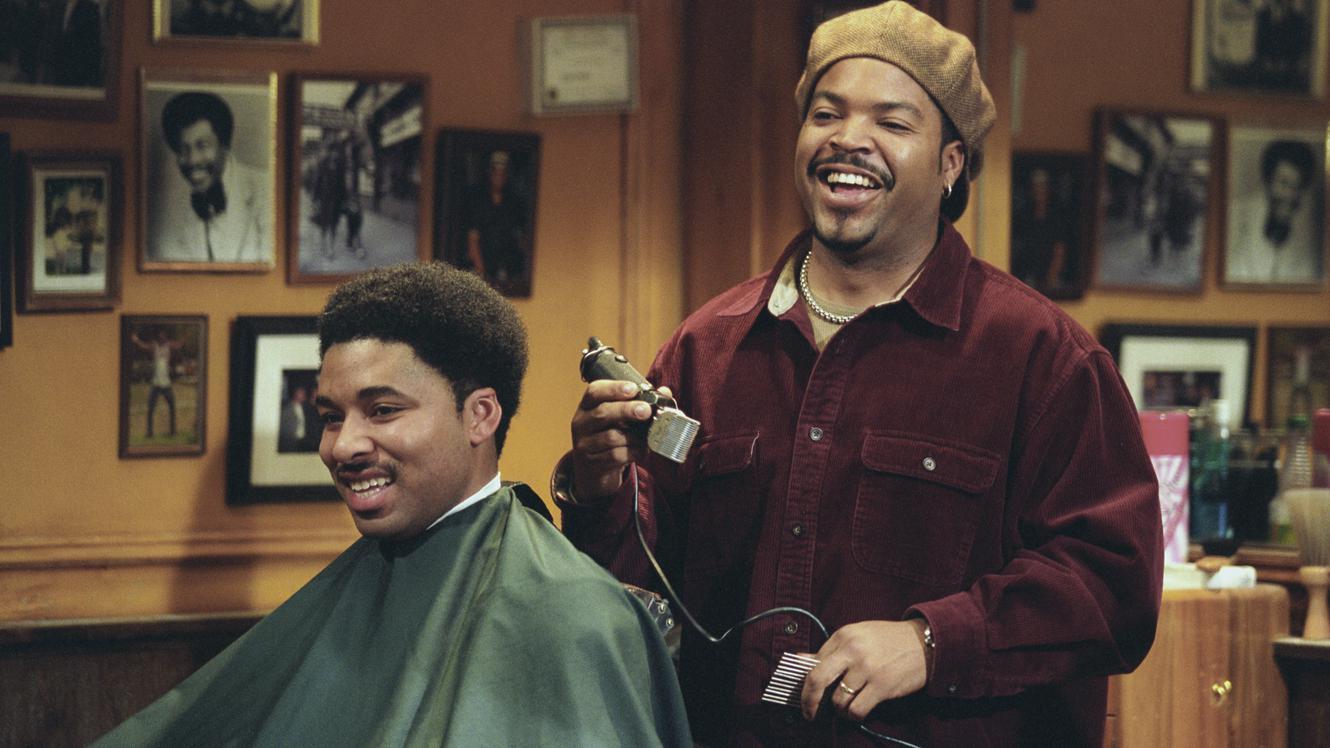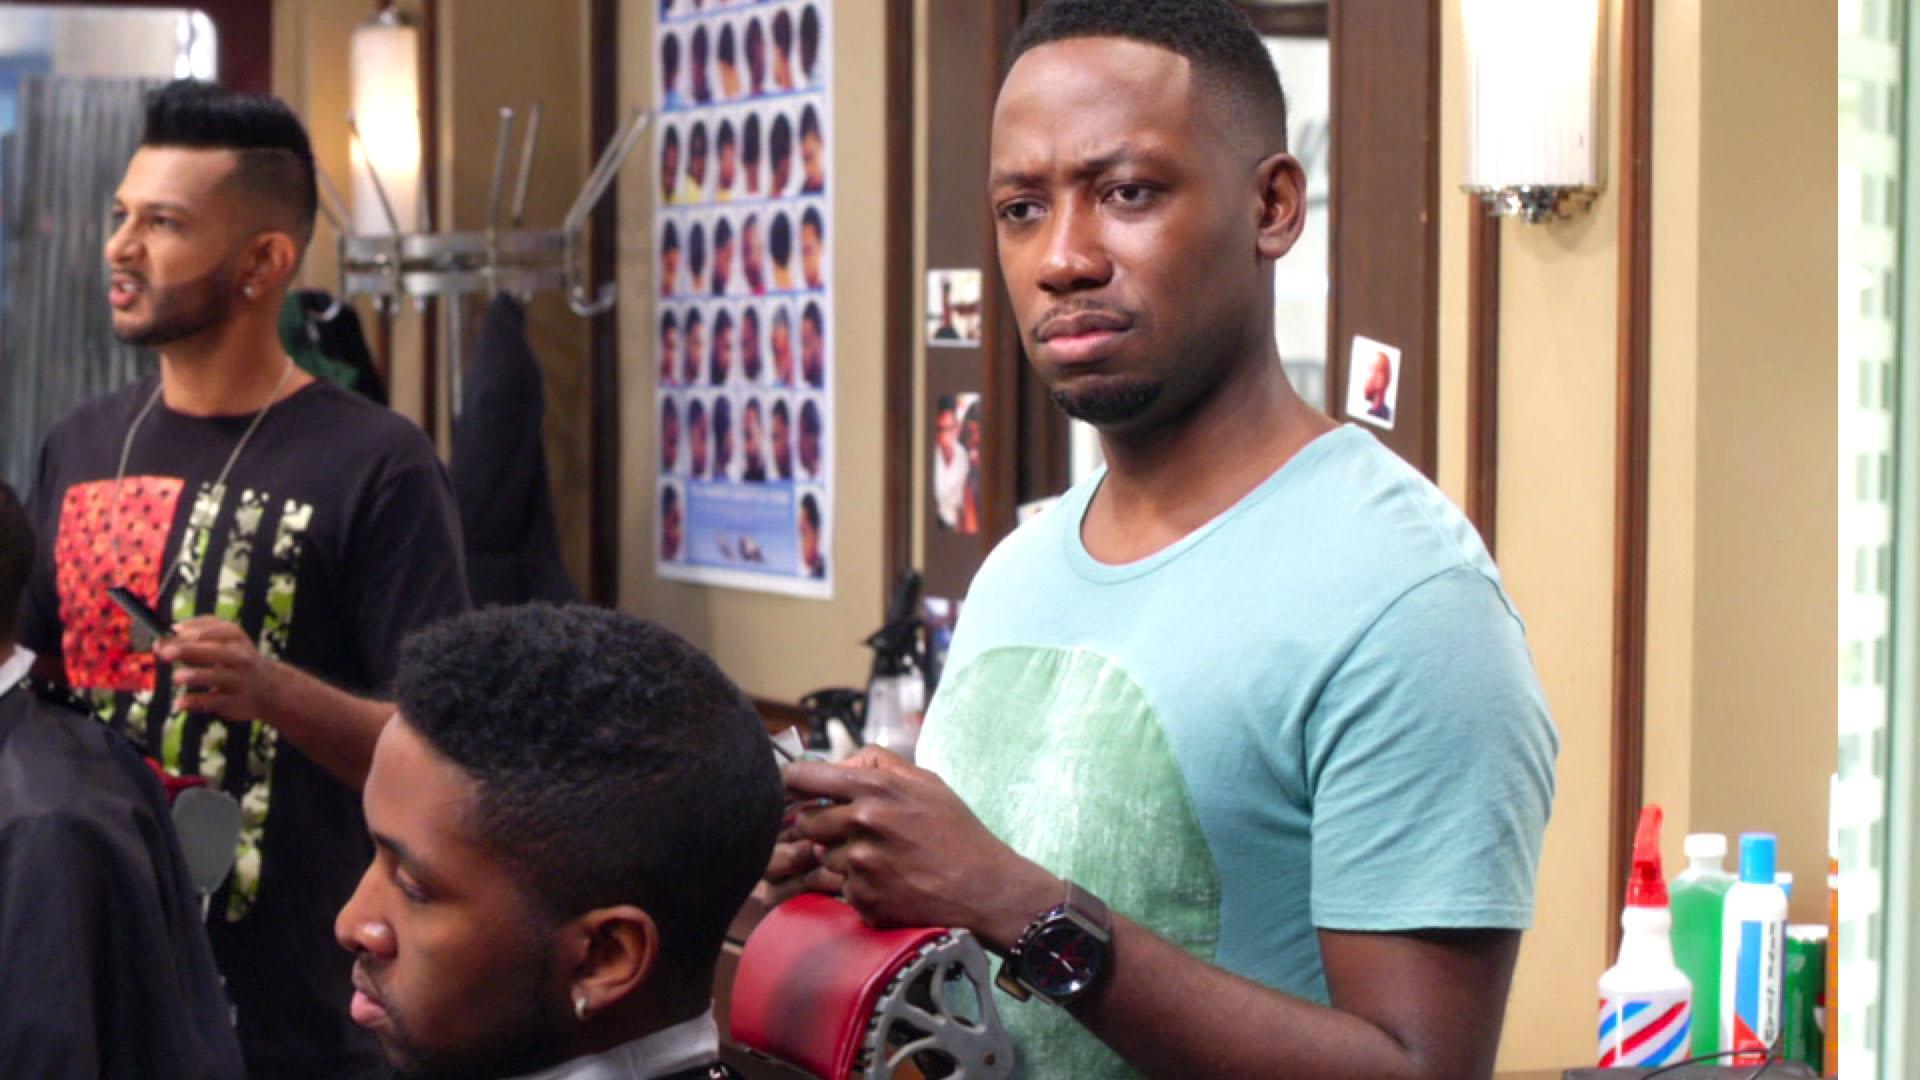The first image is the image on the left, the second image is the image on the right. Analyze the images presented: Is the assertion "All the people are African Americans." valid? Answer yes or no. No. The first image is the image on the left, the second image is the image on the right. Considering the images on both sides, is "There is at least five people in a barber shop." valid? Answer yes or no. Yes. 